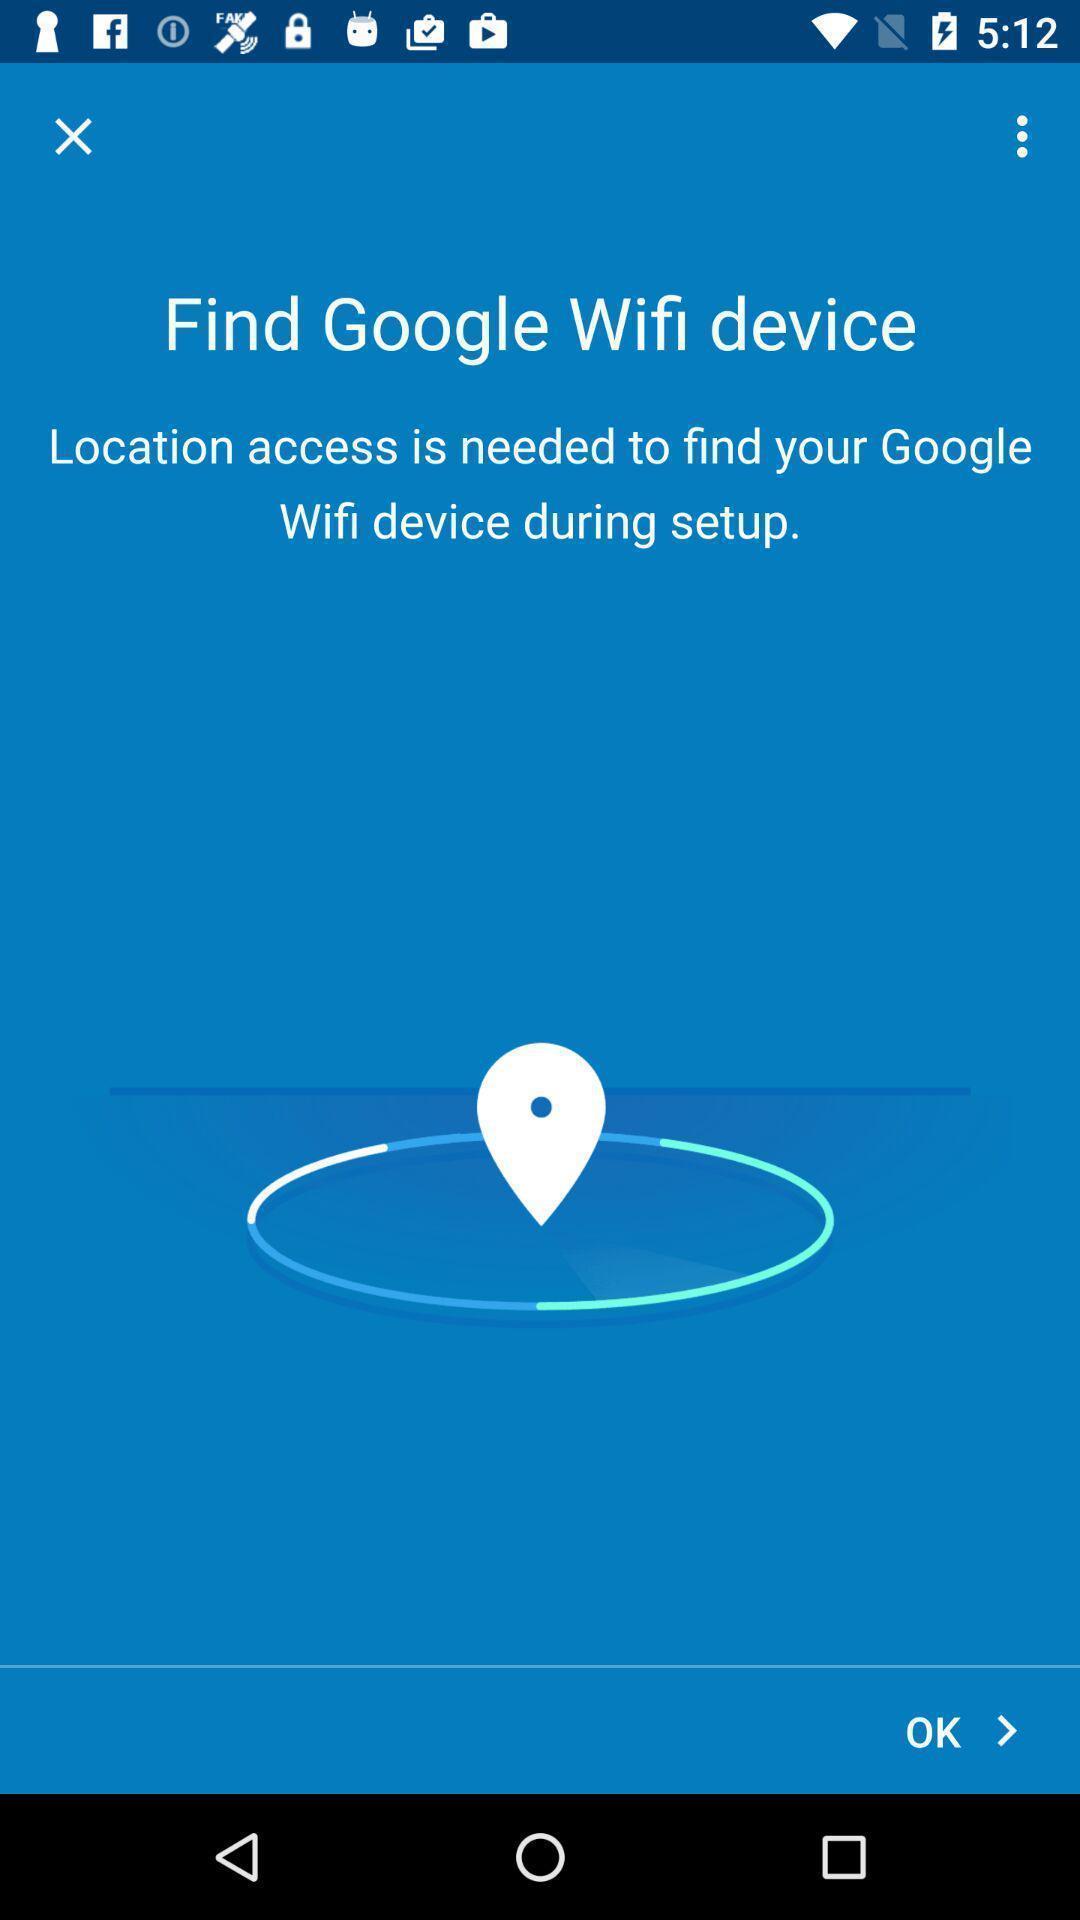Summarize the main components in this picture. Page displaying to find wifi device. 